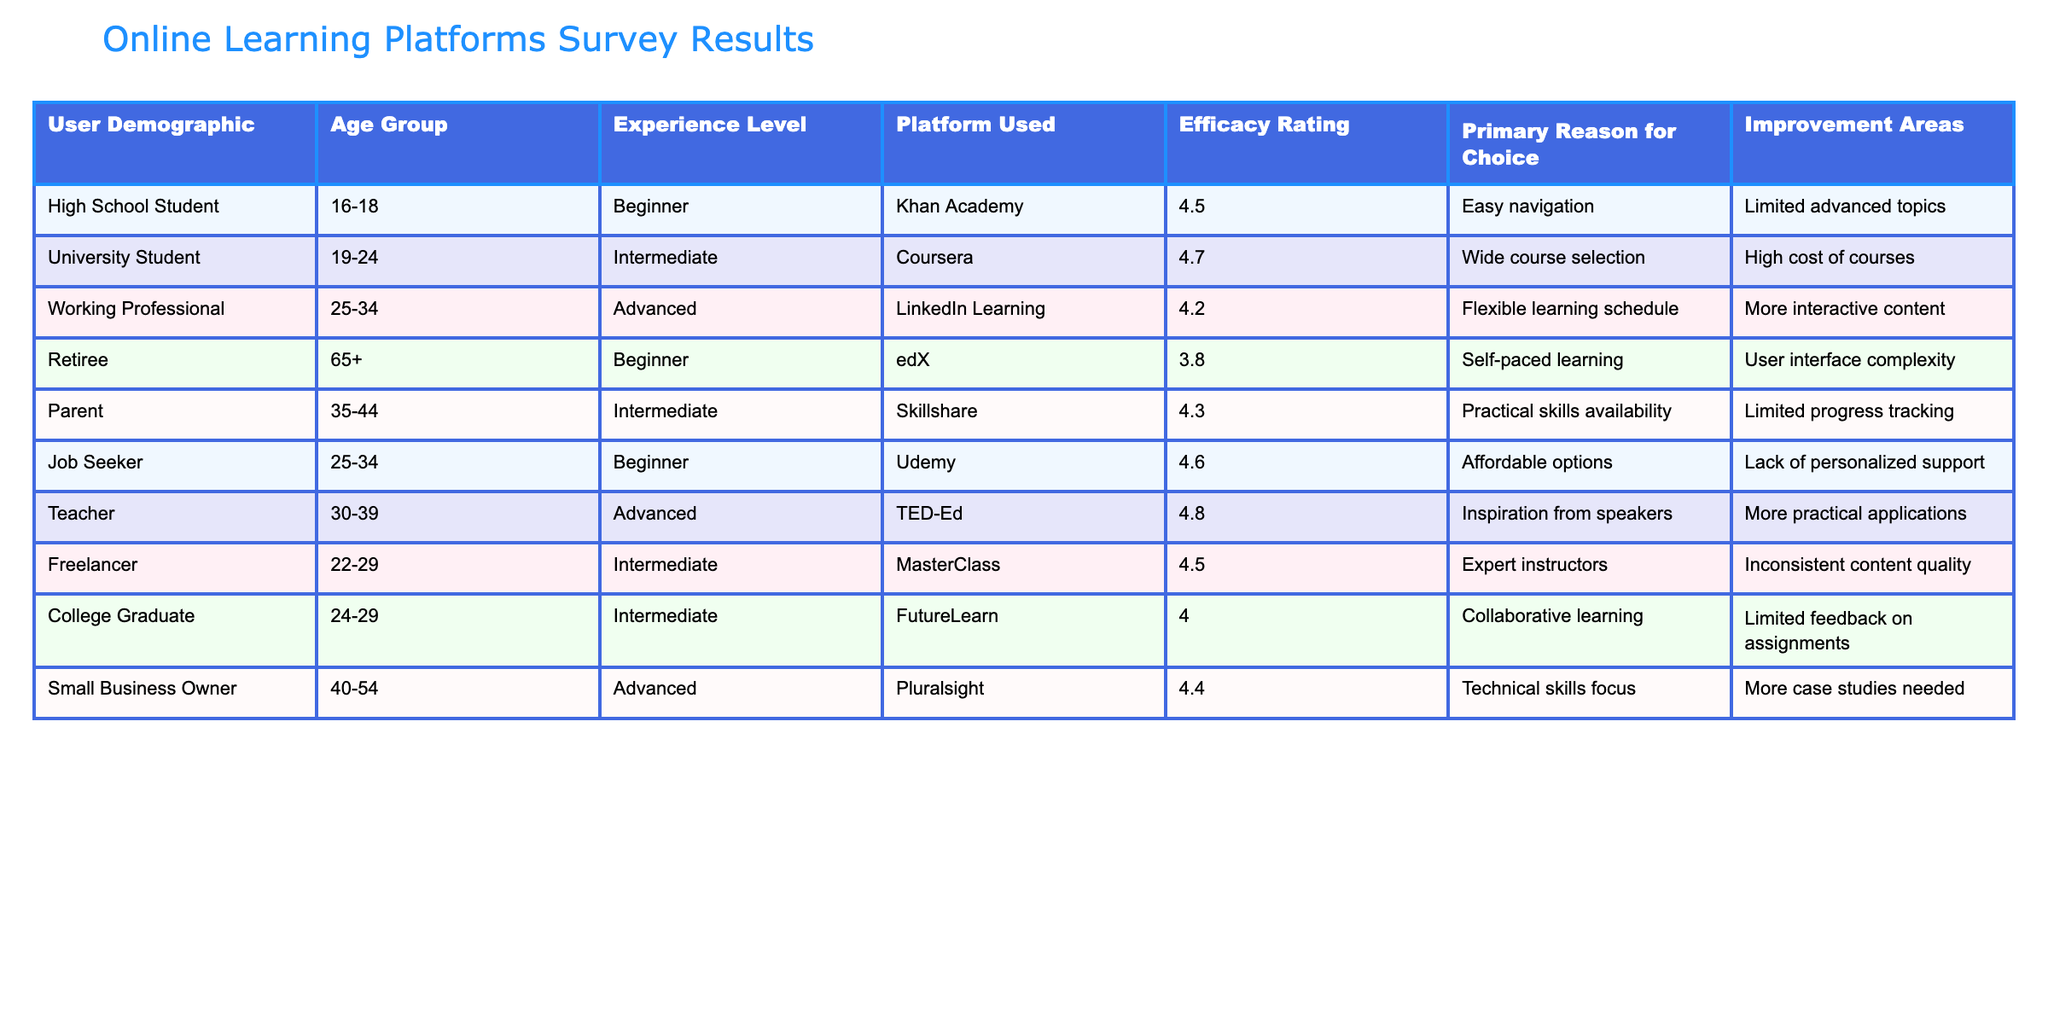What is the efficacy rating for the Teacher demographic? The table shows that the Teacher demographic has an efficacy rating of 4.8, which can be found in the "Efficacy Rating" column corresponding to the "Teacher" row.
Answer: 4.8 Which platform has the highest efficacy rating? The table indicates that TED-Ed has the highest efficacy rating of 4.8, found in the “Efficacy Rating” column.
Answer: TED-Ed What is the average efficacy rating of the platforms used by users aged 25-34? The users aged 25-34 are represented by Working Professional and Job Seeker, with efficacy ratings of 4.2 and 4.6, respectively. The average is calculated as (4.2 + 4.6) / 2 = 4.4.
Answer: 4.4 Is the primary reason for choice of the University Student related to course variety? The primary reason for choice for the University Student demographic is "Wide course selection," which directly indicates a positive relation to course variety.
Answer: Yes What improvement area do both the Working Professional and the Parent demographic mention? The Working Professional mentions "More interactive content" and the Parent states "Limited progress tracking," which are different areas; thus, there is no common improvement area found between them.
Answer: No What is the average rating of platforms used by Beginner users compared to Intermediate users? The Beginner users (Khan Academy - 4.5, edX - 3.8, Udemy - 4.6) have a total of (4.5 + 3.8 + 4.6) = 13.9 from 3 users, giving an average of 13.9 / 3 = 4.63. The Intermediate users (Coursera - 4.7, Skillshare - 4.3, Freelancer - 4.5, FutureLearn - 4.0) have a total of (4.7 + 4.3 + 4.5 + 4.0) = 17.5 from 4 users, giving an average of 17.5 / 4 = 4.375. Since 4.63 is greater than 4.375, the Beginner users have a higher rating.
Answer: Beginner users have a higher rating 